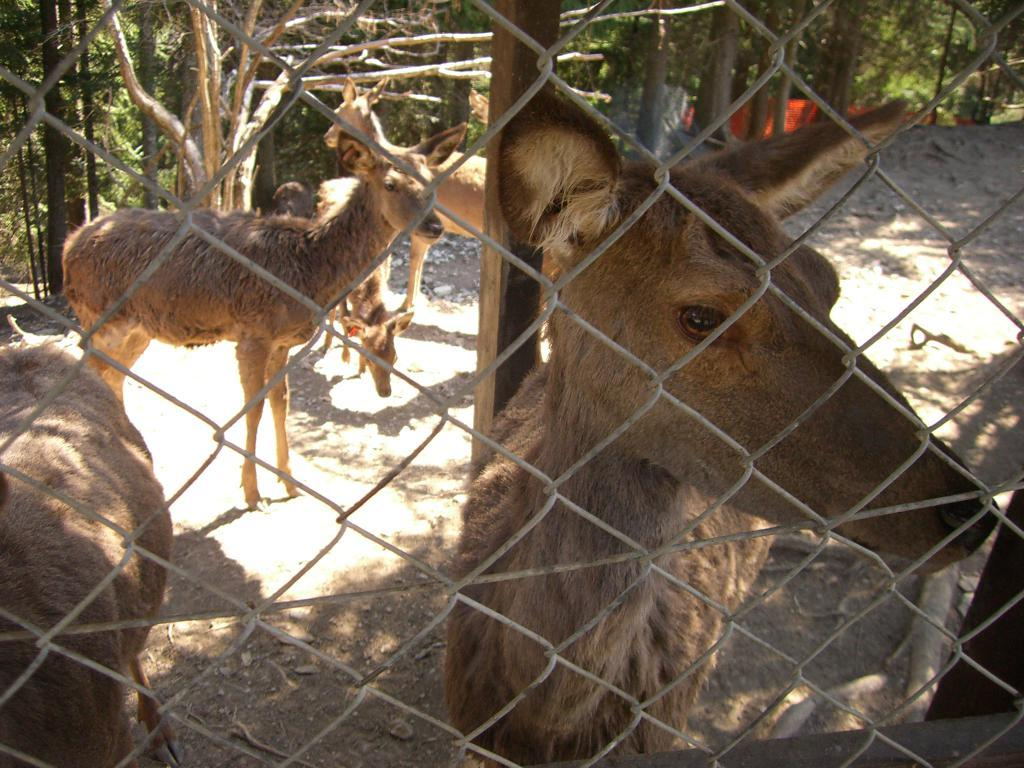What type of living organisms are present in the image? There are animals in the image. Where are the animals located? The animals are in a cage. What objects can be seen in the image besides the animals? Trunks are visible in the image. What type of natural environment is depicted in the image? There are trees in the image. What type of treatment is being administered to the goose in the image? There is no goose present in the image, so no treatment can be observed. 